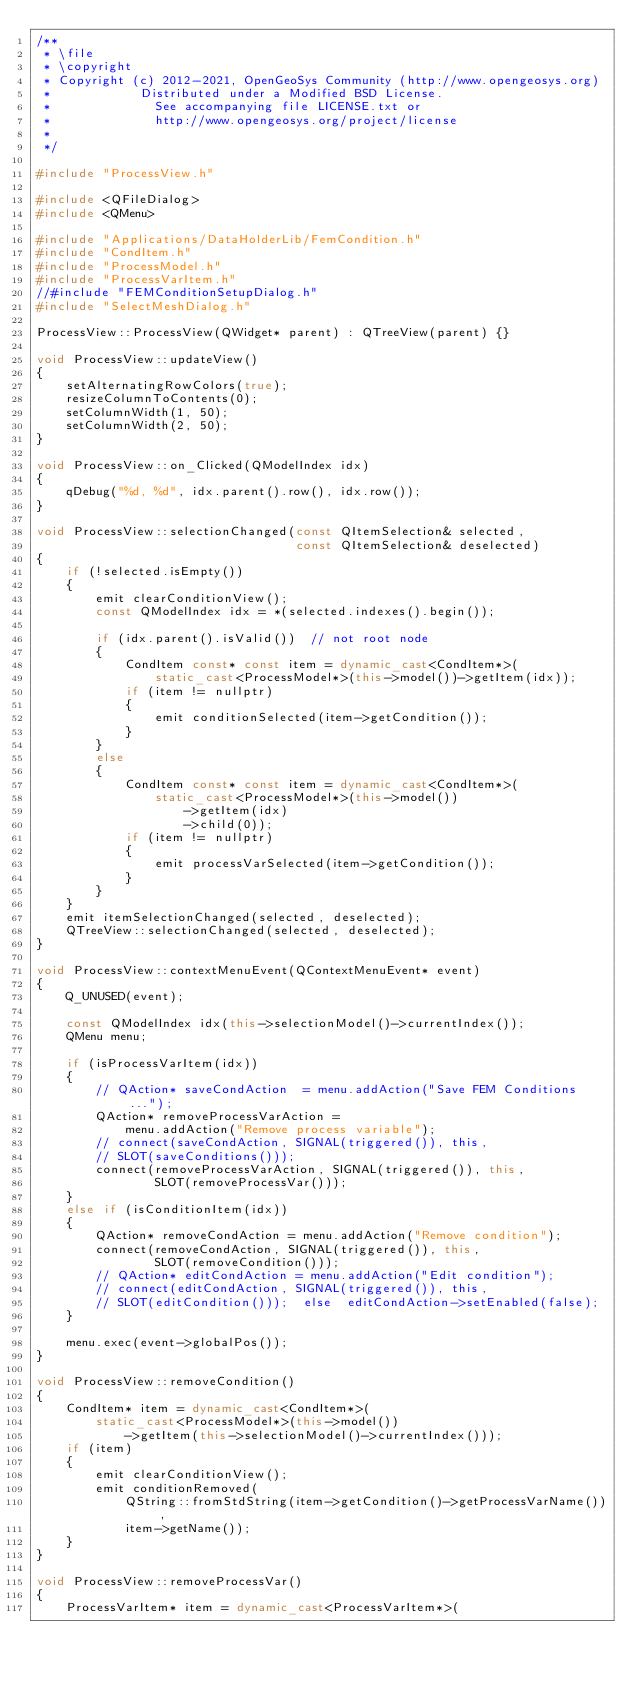Convert code to text. <code><loc_0><loc_0><loc_500><loc_500><_C++_>/**
 * \file
 * \copyright
 * Copyright (c) 2012-2021, OpenGeoSys Community (http://www.opengeosys.org)
 *            Distributed under a Modified BSD License.
 *              See accompanying file LICENSE.txt or
 *              http://www.opengeosys.org/project/license
 *
 */

#include "ProcessView.h"

#include <QFileDialog>
#include <QMenu>

#include "Applications/DataHolderLib/FemCondition.h"
#include "CondItem.h"
#include "ProcessModel.h"
#include "ProcessVarItem.h"
//#include "FEMConditionSetupDialog.h"
#include "SelectMeshDialog.h"

ProcessView::ProcessView(QWidget* parent) : QTreeView(parent) {}

void ProcessView::updateView()
{
    setAlternatingRowColors(true);
    resizeColumnToContents(0);
    setColumnWidth(1, 50);
    setColumnWidth(2, 50);
}

void ProcessView::on_Clicked(QModelIndex idx)
{
    qDebug("%d, %d", idx.parent().row(), idx.row());
}

void ProcessView::selectionChanged(const QItemSelection& selected,
                                   const QItemSelection& deselected)
{
    if (!selected.isEmpty())
    {
        emit clearConditionView();
        const QModelIndex idx = *(selected.indexes().begin());

        if (idx.parent().isValid())  // not root node
        {
            CondItem const* const item = dynamic_cast<CondItem*>(
                static_cast<ProcessModel*>(this->model())->getItem(idx));
            if (item != nullptr)
            {
                emit conditionSelected(item->getCondition());
            }
        }
        else
        {
            CondItem const* const item = dynamic_cast<CondItem*>(
                static_cast<ProcessModel*>(this->model())
                    ->getItem(idx)
                    ->child(0));
            if (item != nullptr)
            {
                emit processVarSelected(item->getCondition());
            }
        }
    }
    emit itemSelectionChanged(selected, deselected);
    QTreeView::selectionChanged(selected, deselected);
}

void ProcessView::contextMenuEvent(QContextMenuEvent* event)
{
    Q_UNUSED(event);

    const QModelIndex idx(this->selectionModel()->currentIndex());
    QMenu menu;

    if (isProcessVarItem(idx))
    {
        // QAction* saveCondAction  = menu.addAction("Save FEM Conditions...");
        QAction* removeProcessVarAction =
            menu.addAction("Remove process variable");
        // connect(saveCondAction, SIGNAL(triggered()), this,
        // SLOT(saveConditions()));
        connect(removeProcessVarAction, SIGNAL(triggered()), this,
                SLOT(removeProcessVar()));
    }
    else if (isConditionItem(idx))
    {
        QAction* removeCondAction = menu.addAction("Remove condition");
        connect(removeCondAction, SIGNAL(triggered()), this,
                SLOT(removeCondition()));
        // QAction* editCondAction = menu.addAction("Edit condition");
        // connect(editCondAction, SIGNAL(triggered()), this,
        // SLOT(editCondition()));  else  editCondAction->setEnabled(false);
    }

    menu.exec(event->globalPos());
}

void ProcessView::removeCondition()
{
    CondItem* item = dynamic_cast<CondItem*>(
        static_cast<ProcessModel*>(this->model())
            ->getItem(this->selectionModel()->currentIndex()));
    if (item)
    {
        emit clearConditionView();
        emit conditionRemoved(
            QString::fromStdString(item->getCondition()->getProcessVarName()),
            item->getName());
    }
}

void ProcessView::removeProcessVar()
{
    ProcessVarItem* item = dynamic_cast<ProcessVarItem*>(</code> 